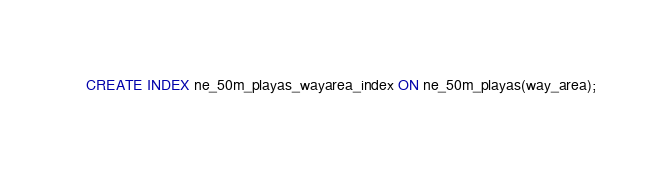Convert code to text. <code><loc_0><loc_0><loc_500><loc_500><_SQL_>CREATE INDEX ne_50m_playas_wayarea_index ON ne_50m_playas(way_area);
</code> 